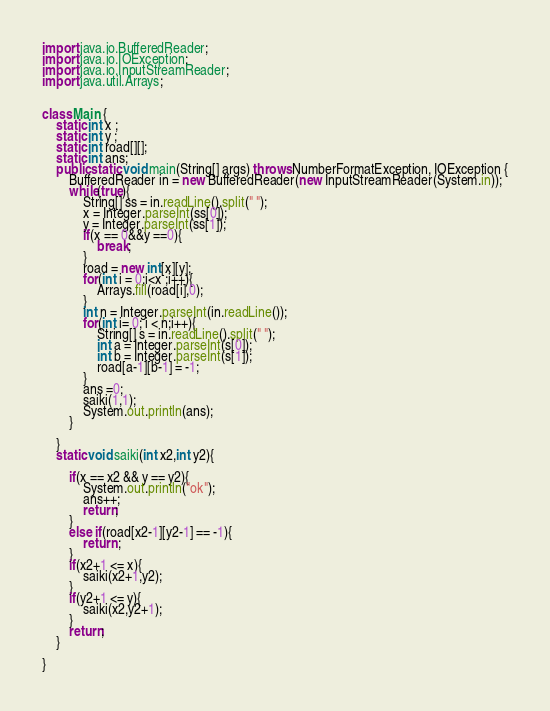Convert code to text. <code><loc_0><loc_0><loc_500><loc_500><_Java_>import java.io.BufferedReader;
import java.io.IOException;
import java.io.InputStreamReader;
import java.util.Arrays;


class Main {
	static int x ;
	static int y ;
	static int road[][];
	static int ans;
	public static void main(String[] args) throws NumberFormatException, IOException {
		BufferedReader in = new BufferedReader(new InputStreamReader(System.in));
		while(true){
			String[] ss = in.readLine().split(" ");
			x = Integer.parseInt(ss[0]);
			y = Integer.parseInt(ss[1]);
			if(x == 0&&y ==0){
				break;
			}
			road = new int[x][y];
			for(int i = 0;i<x ;i++){
				Arrays.fill(road[i],0);
			}
			int n = Integer.parseInt(in.readLine());
			for(int i= 0; i < n;i++){
				String[] s = in.readLine().split(" ");
				int a = Integer.parseInt(s[0]);
				int b = Integer.parseInt(s[1]);
				road[a-1][b-1] = -1;
			}
			ans =0;
			saiki(1,1);
			System.out.println(ans);
		}	

	}
	static void saiki(int x2,int y2){
		
		if(x == x2 && y == y2){
			System.out.println("ok");
			ans++;
			return;
		}
		else if(road[x2-1][y2-1] == -1){
			return ;
		}
		if(x2+1 <= x){
			saiki(x2+1,y2);
		}
		if(y2+1 <= y){
			saiki(x2,y2+1);
		}
		return;
	}

}</code> 